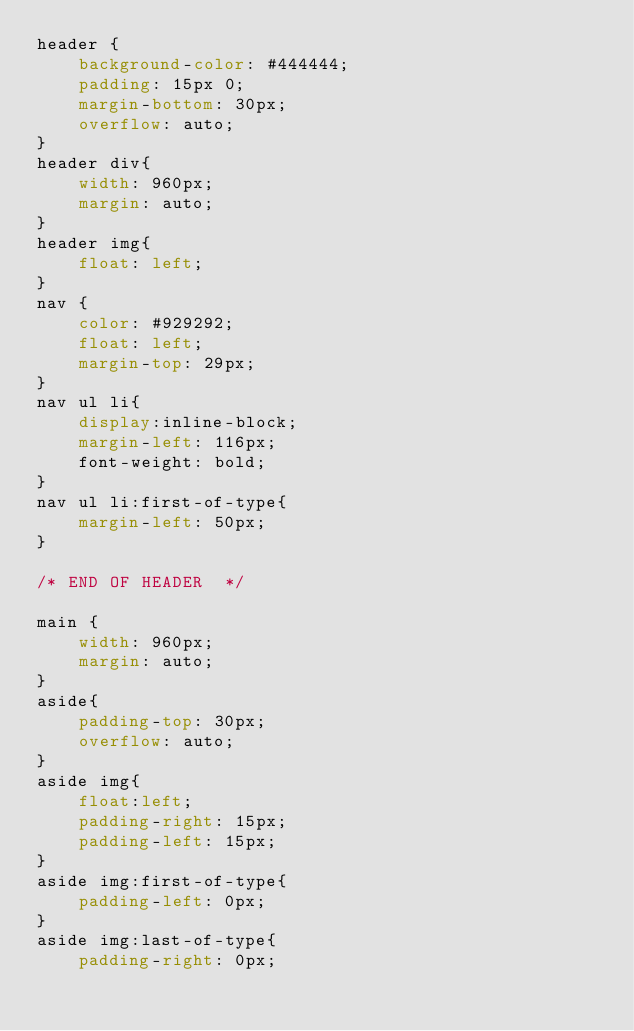<code> <loc_0><loc_0><loc_500><loc_500><_CSS_>header {
    background-color: #444444;
    padding: 15px 0;
    margin-bottom: 30px;
    overflow: auto;
}
header div{
    width: 960px;
    margin: auto;
}
header img{
    float: left;
}
nav {
    color: #929292;
    float: left;
    margin-top: 29px;
}
nav ul li{
    display:inline-block;
    margin-left: 116px;
    font-weight: bold;
}
nav ul li:first-of-type{
    margin-left: 50px;
}

/* END OF HEADER  */

main {
    width: 960px;
    margin: auto;
}
aside{
    padding-top: 30px;
    overflow: auto;
}
aside img{
    float:left;
    padding-right: 15px;
    padding-left: 15px;
}
aside img:first-of-type{
    padding-left: 0px;
}
aside img:last-of-type{
    padding-right: 0px;</code> 